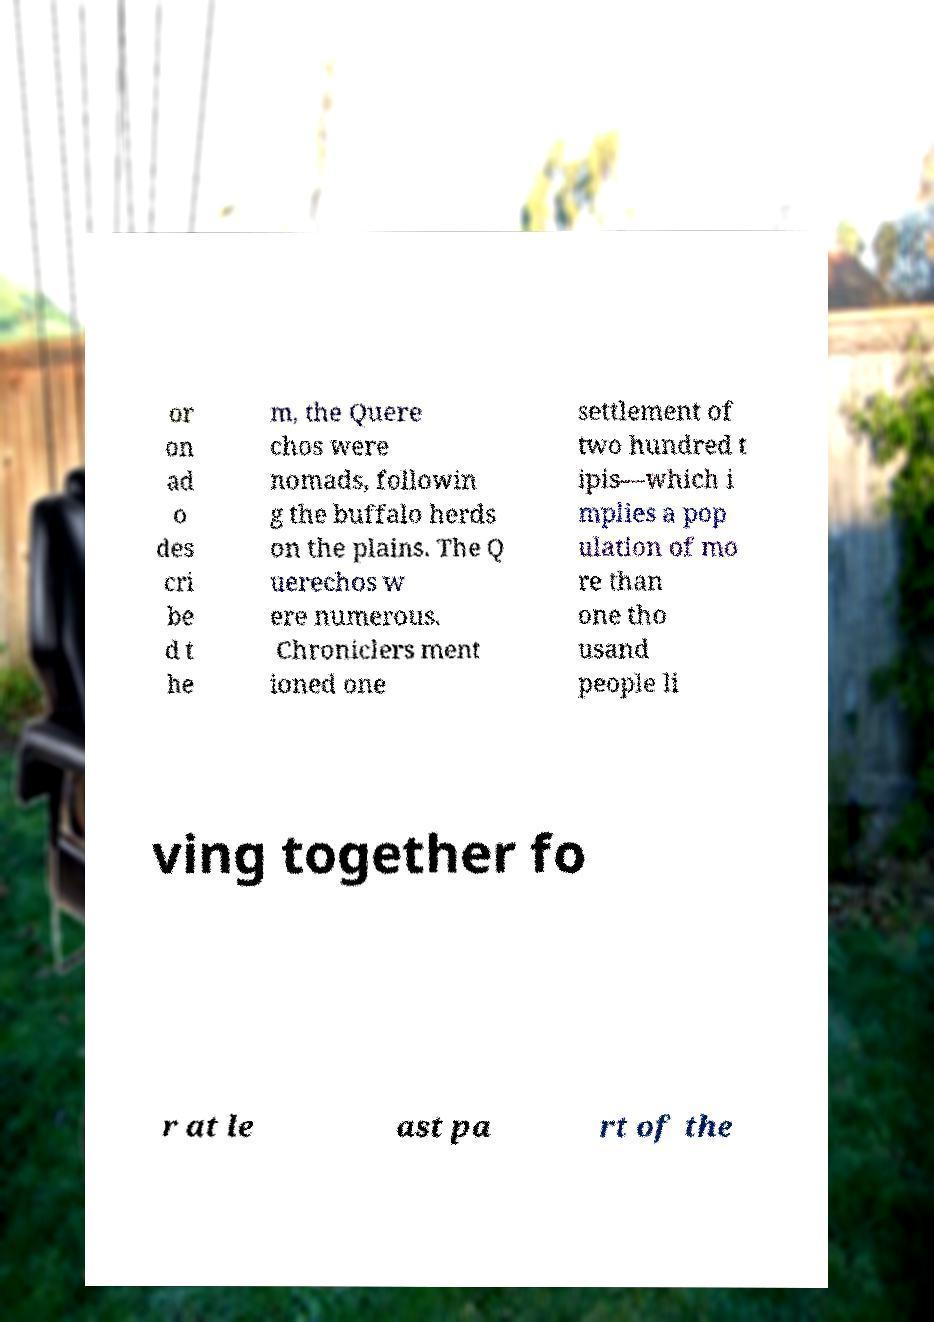Please identify and transcribe the text found in this image. or on ad o des cri be d t he m, the Quere chos were nomads, followin g the buffalo herds on the plains. The Q uerechos w ere numerous. Chroniclers ment ioned one settlement of two hundred t ipis—which i mplies a pop ulation of mo re than one tho usand people li ving together fo r at le ast pa rt of the 